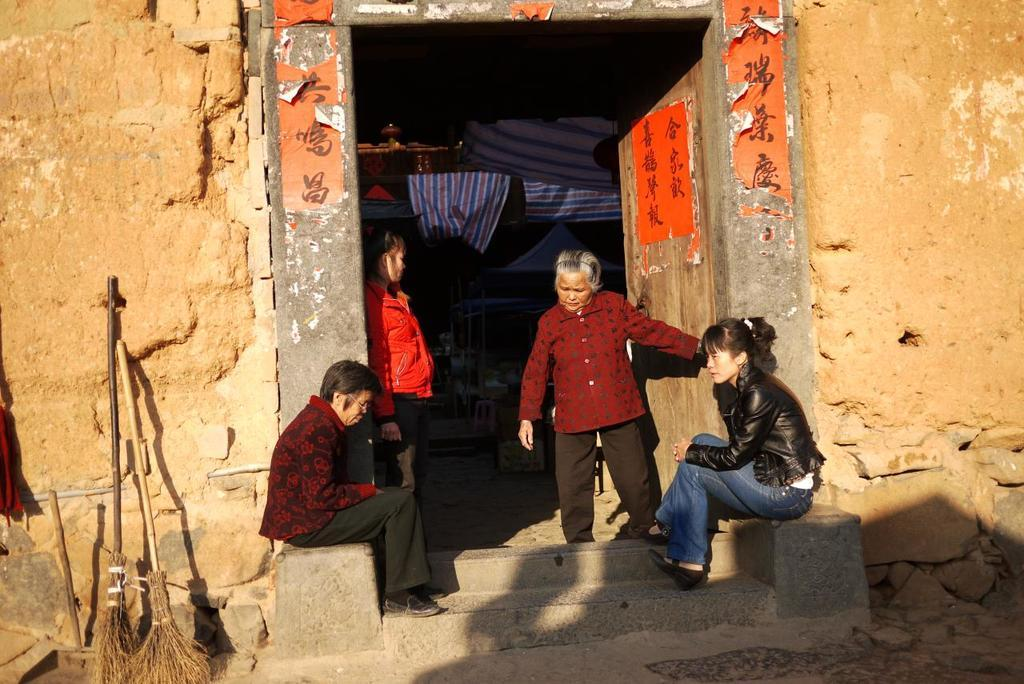How many people are present in the image? There are people standing in the image, but the exact number is not specified. What are the people in the image doing? The fact only mentions that there are people standing, so we cannot determine their actions. What is the main architectural feature in the image? There is a wall in the image, and a door is located in the middle of the wall. What type of music can be heard coming from the zoo in the image? There is no mention of a zoo or music in the image, so it is not possible to determine what type of music might be heard. 